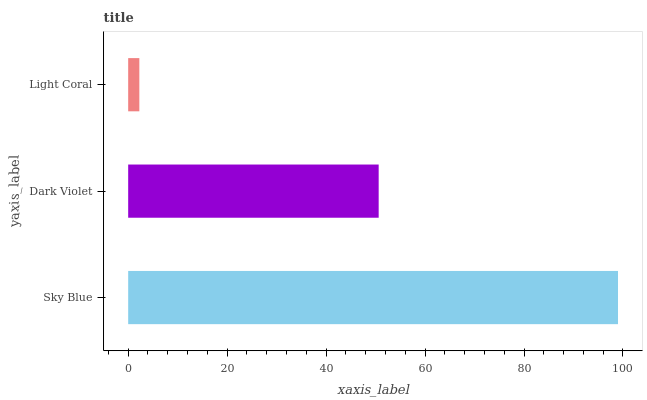Is Light Coral the minimum?
Answer yes or no. Yes. Is Sky Blue the maximum?
Answer yes or no. Yes. Is Dark Violet the minimum?
Answer yes or no. No. Is Dark Violet the maximum?
Answer yes or no. No. Is Sky Blue greater than Dark Violet?
Answer yes or no. Yes. Is Dark Violet less than Sky Blue?
Answer yes or no. Yes. Is Dark Violet greater than Sky Blue?
Answer yes or no. No. Is Sky Blue less than Dark Violet?
Answer yes or no. No. Is Dark Violet the high median?
Answer yes or no. Yes. Is Dark Violet the low median?
Answer yes or no. Yes. Is Sky Blue the high median?
Answer yes or no. No. Is Sky Blue the low median?
Answer yes or no. No. 